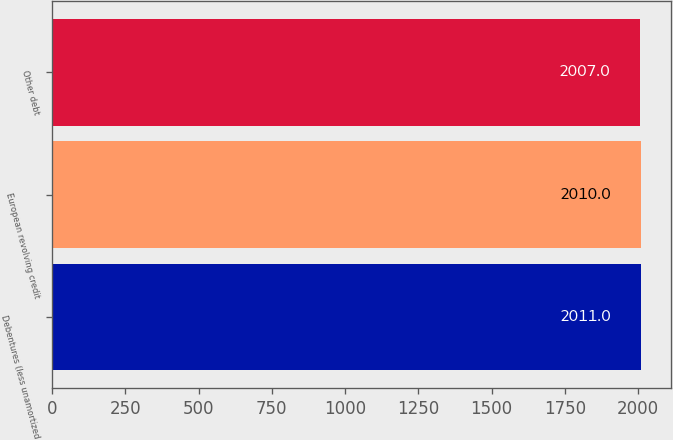<chart> <loc_0><loc_0><loc_500><loc_500><bar_chart><fcel>Debentures (less unamortized<fcel>European revolving credit<fcel>Other debt<nl><fcel>2011<fcel>2010<fcel>2007<nl></chart> 